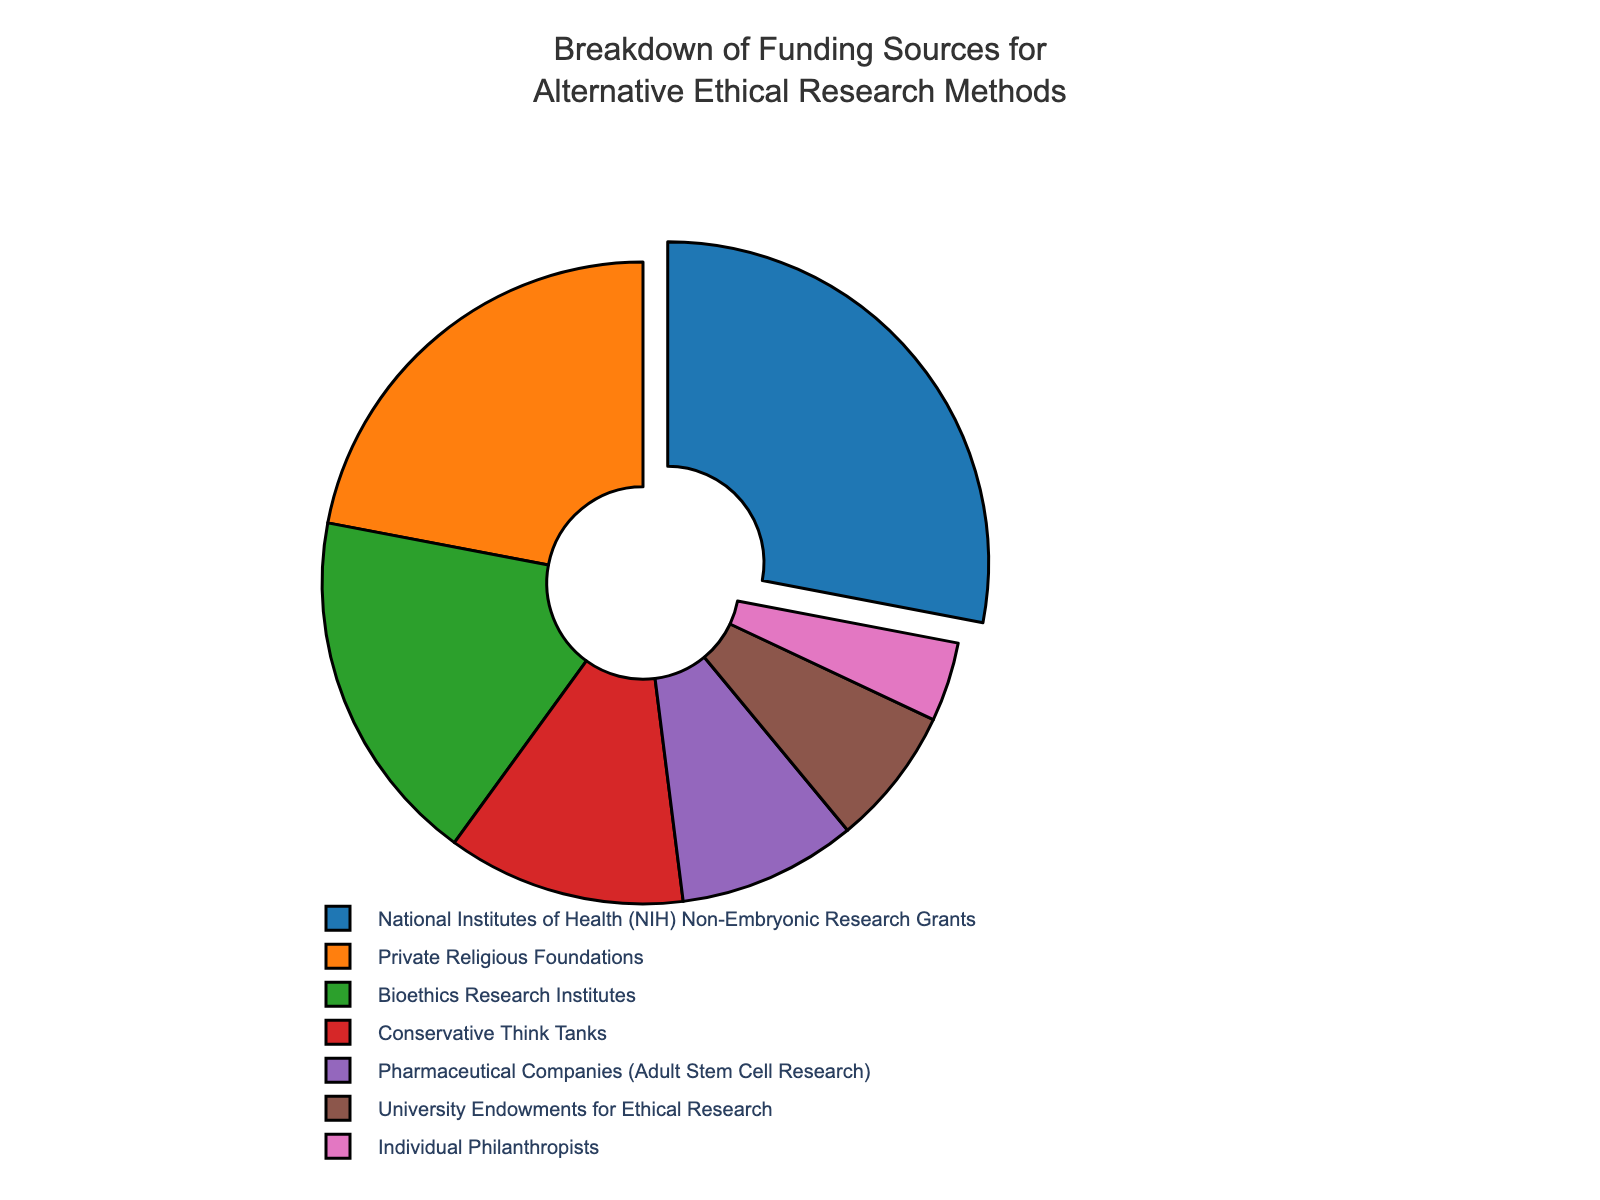What percentage of funding comes from conservative think tanks and individual philanthropists combined? To find the combined percentage, add the percentages from conservative think tanks (12%) and individual philanthropists (4%). The total is 12 + 4 = 16%
Answer: 16% Which funding source has the highest percentage, and what is that percentage? The pie chart shows that NIH Non-Embryonic Research Grants has the highest percentage, which is 28%.
Answer: NIH Non-Embryonic Research Grants, 28% How much higher is the percentage of private religious foundations compared to pharmaceutical companies? The percentage for private religious foundations is 22%, and for pharmaceutical companies, it is 9%. The difference is 22 - 9 = 13%
Answer: 13% What is the total percentage of funding contributed by private religious foundations, bioethics research institutes, and pharmaceutical companies? Add the percentages: private religious foundations (22%), bioethics research institutes (18%), and pharmaceutical companies (9%). The total is 22 + 18 + 9 = 49%
Answer: 49% Which funding source contributes the least, and what is that percentage? The chart shows that individual philanthropists contribute the least at 4%.
Answer: Individual Philanthropists, 4% What is the percentage contribution from National Institutes of Health (NIH) Non-Embryonic Research Grants compared to university endowments for ethical research? NIH Non-Embryonic Research Grants contribute 28%, while university endowments contribute 7%.
Answer: NIH Non-Embryonic Research Grants, 28%, University Endowments, 7% Is the contribution from pharmaceutical companies more or less than half of that from bioethics research institutes? The percentage for pharmaceutical companies is 9%, and for bioethics research institutes, it is 18%. Half of 18% is 9%, so the pharmaceutical companies' contribution is equal to half of that from bioethics research institutes.
Answer: Equal to What is the combined percentage of funding from sources other than the top two contributors? The top two contributors are NIH Non-Embryonic Research Grants (28%) and private religious foundations (22%). Sum the remaining: bioethics research institutes (18%), conservative think tanks (12%), pharmaceutical companies (9%), university endowments (7%), individual philanthropists (4%). The total is 18 + 12 + 9 + 7 + 4 = 50%
Answer: 50% What is the visual indicator for the segment representing the NIH Non-Embryonic Research Grants on the pie chart? The NIH Non-Embryonic Research Grants segment is slightly pulled outwards compared to the other segments.
Answer: Pulled outwards 